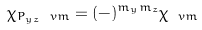Convert formula to latex. <formula><loc_0><loc_0><loc_500><loc_500>\chi _ { P _ { y z } \ v m } = ( - ) ^ { m _ { y } m _ { z } } \chi _ { \ v m }</formula> 